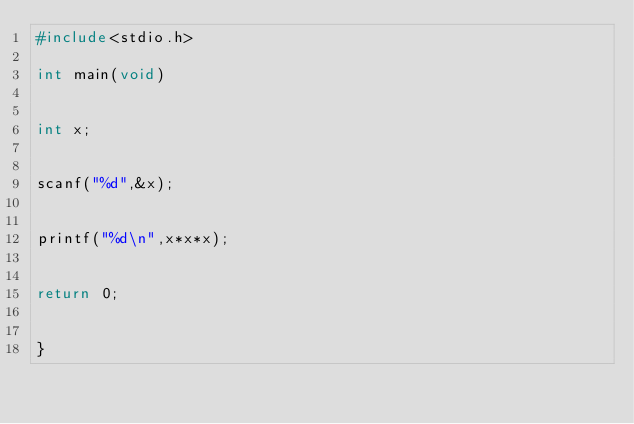Convert code to text. <code><loc_0><loc_0><loc_500><loc_500><_C_>#include<stdio.h>

int main(void)


int x;


scanf("%d",&x);


printf("%d\n",x*x*x);


return 0;


}</code> 